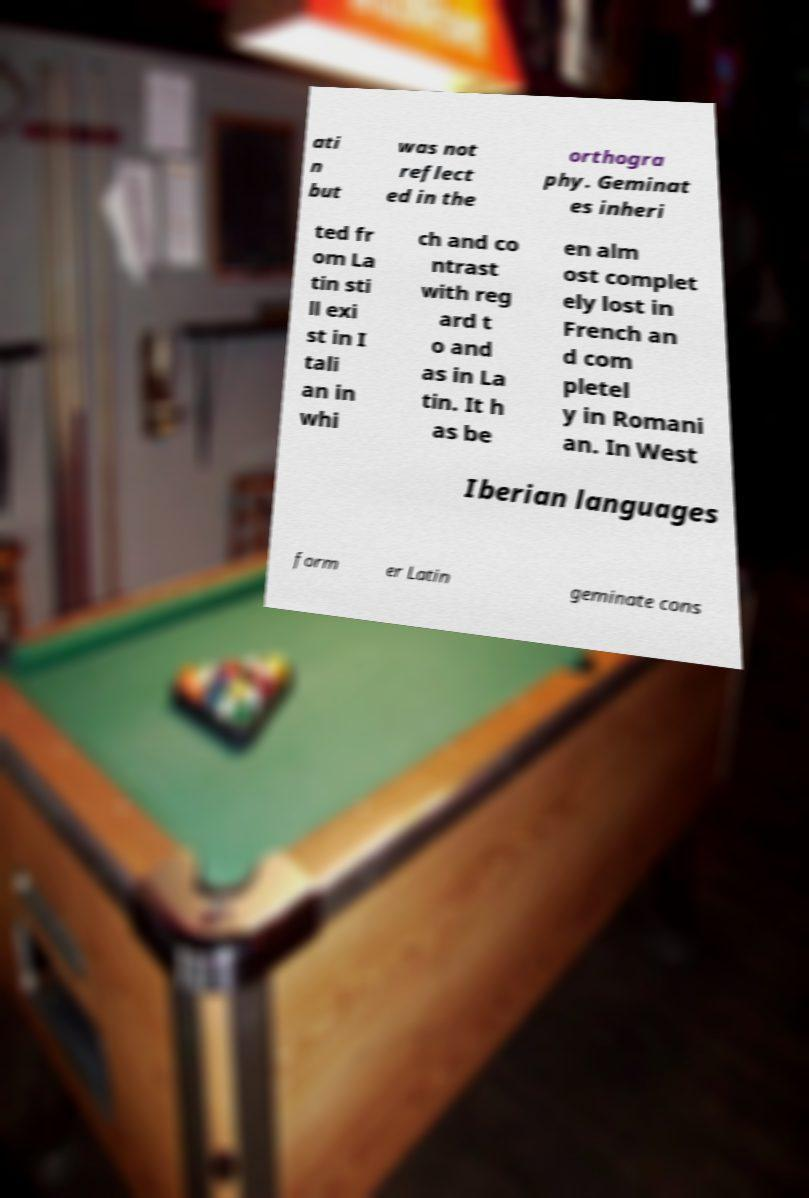Please read and relay the text visible in this image. What does it say? ati n but was not reflect ed in the orthogra phy. Geminat es inheri ted fr om La tin sti ll exi st in I tali an in whi ch and co ntrast with reg ard t o and as in La tin. It h as be en alm ost complet ely lost in French an d com pletel y in Romani an. In West Iberian languages form er Latin geminate cons 